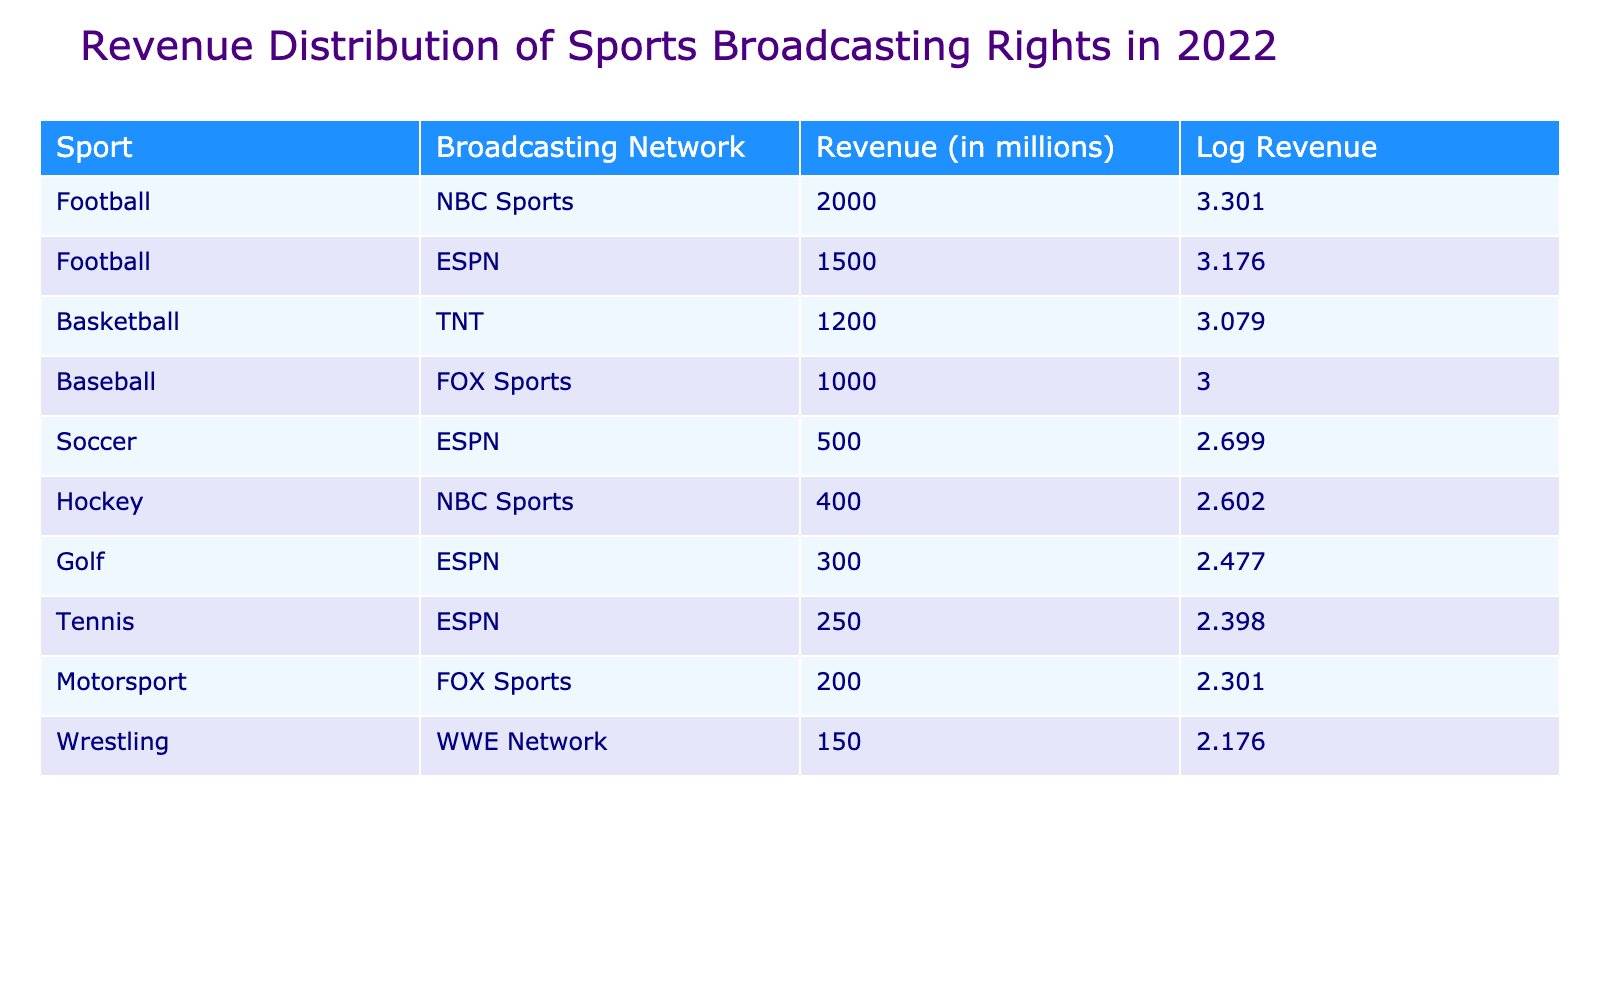What is the revenue of NBC Sports for football? The table lists the revenue for NBC Sports under the football category as 2000 million.
Answer: 2000 million Which sport has the lowest revenue in the table? By examining the revenue values, the sport with the lowest reported revenue is wrestling, which brings in 150 million.
Answer: Wrestling What is the total revenue for ESPN across all sports? To find the total revenue for ESPN, we sum the revenue for soccer (500 million), golf (300 million), tennis (250 million), and football (1500 million). The calculation is 500 + 300 + 250 + 1500 = 2550 million.
Answer: 2550 million Is the revenue for motorsport greater than the revenue for tennis? The table indicates that motorsport revenue is 200 million while tennis revenue is 250 million. Since 200 is less than 250, the answer is no.
Answer: No What is the average revenue of the sports listed in the table? First, we find the total revenue by adding all the values: 2000 + 1500 + 1200 + 1000 + 500 + 400 + 300 + 250 + 200 + 150 = 5100 million. Since there are 10 sports listed, we divide this total by 10, resulting in an average of 510.
Answer: 510 million Which broadcasting network covers the sport of hockey, and what is its revenue? The table shows that hockey is covered by NBC Sports and has a revenue of 400 million.
Answer: NBC Sports; 400 million What is the difference in revenue between football and baseball? Football has a revenue of 2000 million and baseball has 1000 million. Calculating the difference gives us 2000 - 1000 = 1000 million.
Answer: 1000 million Does ESPN have the highest total revenue among all broadcasting networks? To determine this, we compare ESPN's total (2500 million) with each network's revenue. NBC Sports has a higher revenue (2400 million from football and hockey) so ESPN does not have the highest total.
Answer: No 